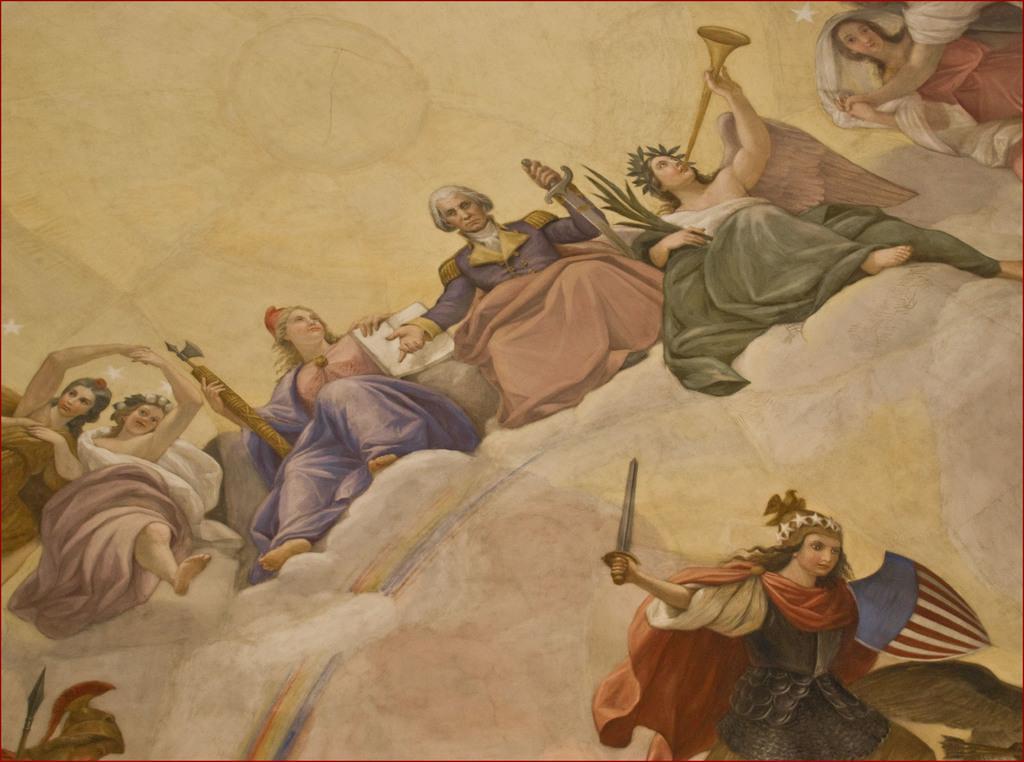How would you summarize this image in a sentence or two? In this image there is painting of persons on the surface, there is a person holding an object, there is a person playing a musical instrument, there is a person sitting and holding a sword, towards the right of the image there is a person truncated, towards the right of the image there is a person truncated, there are stars in the image. 